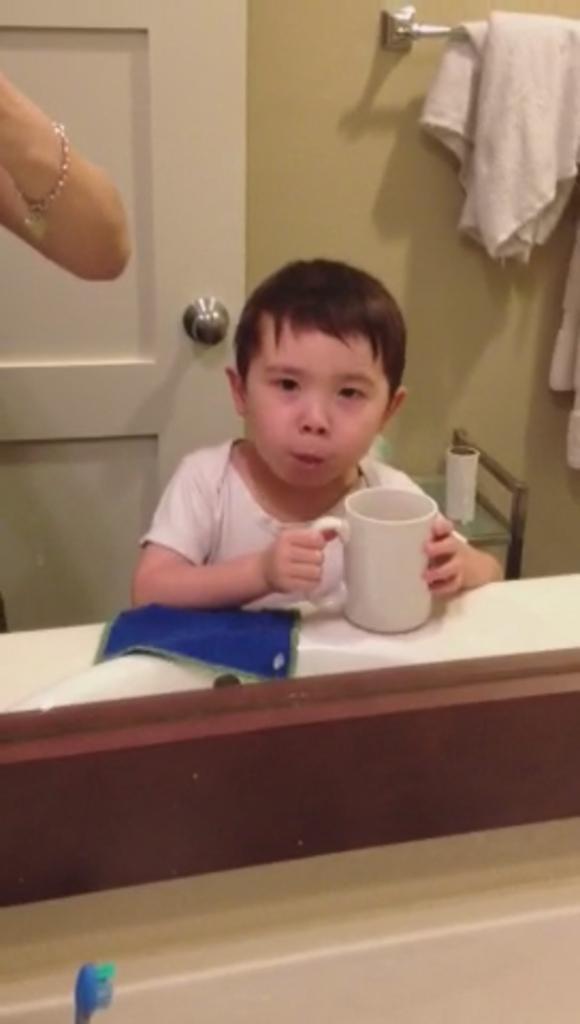Can you describe this image briefly? This image has a kid who is holding a mug in his hand. There is a door behind him and a table on which a tissue roll is placed. There is also a towel on the right side top corner. On the left side there is a hand of someone who has bracelet to their hand. On the left side bottom corner there is a toothbrush. 